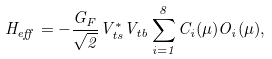Convert formula to latex. <formula><loc_0><loc_0><loc_500><loc_500>H _ { e f f } = - { \frac { G _ { F } } { \sqrt { 2 } } } V _ { t s } ^ { * } V _ { t b } \sum _ { i = 1 } ^ { 8 } C _ { i } ( \mu ) O _ { i } ( \mu ) ,</formula> 